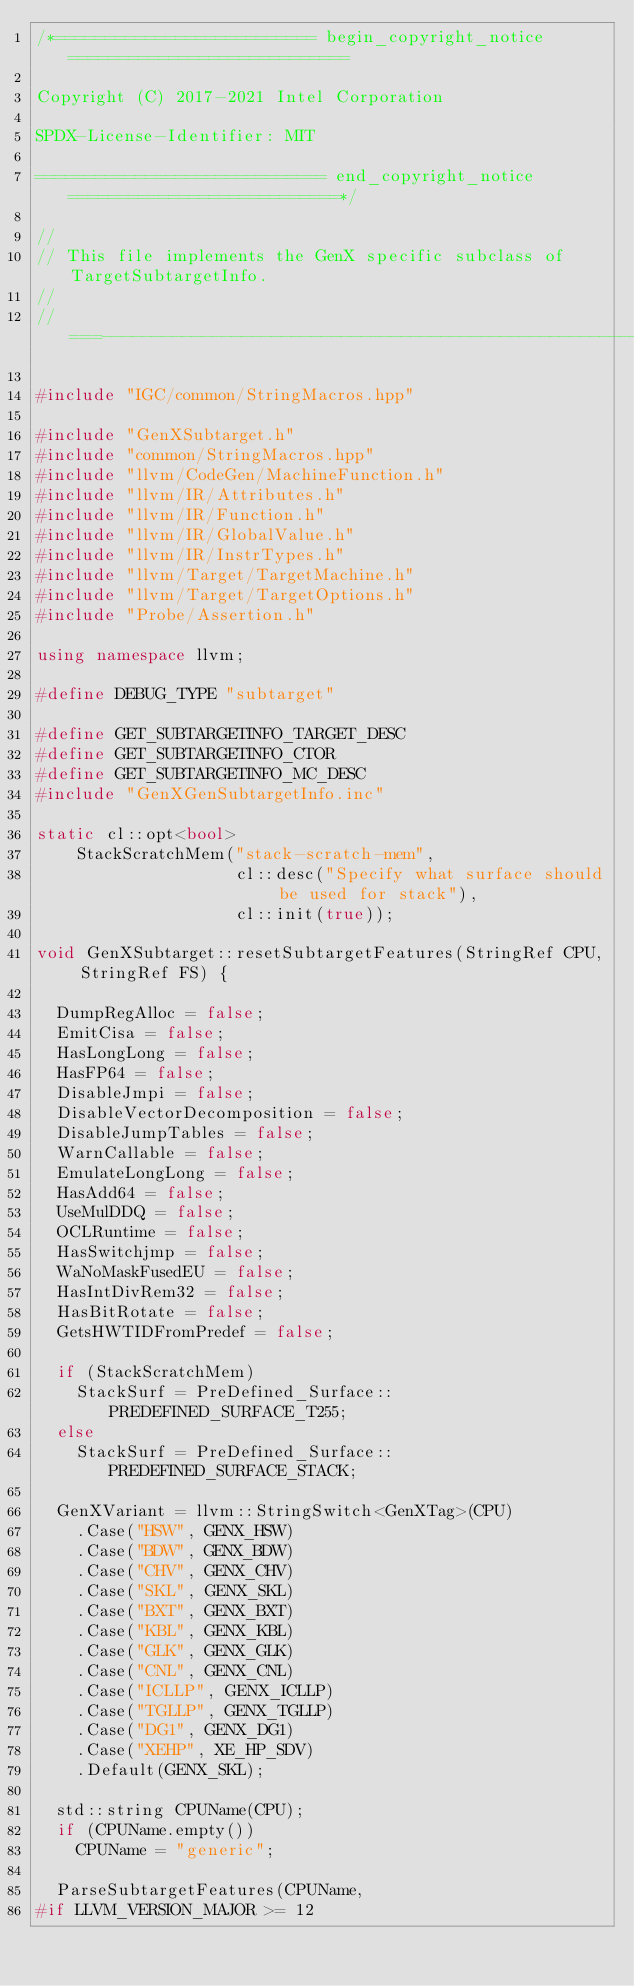<code> <loc_0><loc_0><loc_500><loc_500><_C++_>/*========================== begin_copyright_notice ============================

Copyright (C) 2017-2021 Intel Corporation

SPDX-License-Identifier: MIT

============================= end_copyright_notice ===========================*/

//
// This file implements the GenX specific subclass of TargetSubtargetInfo.
//
//===----------------------------------------------------------------------===//

#include "IGC/common/StringMacros.hpp"

#include "GenXSubtarget.h"
#include "common/StringMacros.hpp"
#include "llvm/CodeGen/MachineFunction.h"
#include "llvm/IR/Attributes.h"
#include "llvm/IR/Function.h"
#include "llvm/IR/GlobalValue.h"
#include "llvm/IR/InstrTypes.h"
#include "llvm/Target/TargetMachine.h"
#include "llvm/Target/TargetOptions.h"
#include "Probe/Assertion.h"

using namespace llvm;

#define DEBUG_TYPE "subtarget"

#define GET_SUBTARGETINFO_TARGET_DESC
#define GET_SUBTARGETINFO_CTOR
#define GET_SUBTARGETINFO_MC_DESC
#include "GenXGenSubtargetInfo.inc"

static cl::opt<bool>
    StackScratchMem("stack-scratch-mem",
                    cl::desc("Specify what surface should be used for stack"),
                    cl::init(true));

void GenXSubtarget::resetSubtargetFeatures(StringRef CPU, StringRef FS) {

  DumpRegAlloc = false;
  EmitCisa = false;
  HasLongLong = false;
  HasFP64 = false;
  DisableJmpi = false;
  DisableVectorDecomposition = false;
  DisableJumpTables = false;
  WarnCallable = false;
  EmulateLongLong = false;
  HasAdd64 = false;
  UseMulDDQ = false;
  OCLRuntime = false;
  HasSwitchjmp = false;
  WaNoMaskFusedEU = false;
  HasIntDivRem32 = false;
  HasBitRotate = false;
  GetsHWTIDFromPredef = false;

  if (StackScratchMem)
    StackSurf = PreDefined_Surface::PREDEFINED_SURFACE_T255;
  else
    StackSurf = PreDefined_Surface::PREDEFINED_SURFACE_STACK;

  GenXVariant = llvm::StringSwitch<GenXTag>(CPU)
    .Case("HSW", GENX_HSW)
    .Case("BDW", GENX_BDW)
    .Case("CHV", GENX_CHV)
    .Case("SKL", GENX_SKL)
    .Case("BXT", GENX_BXT)
    .Case("KBL", GENX_KBL)
    .Case("GLK", GENX_GLK)
    .Case("CNL", GENX_CNL)
    .Case("ICLLP", GENX_ICLLP)
    .Case("TGLLP", GENX_TGLLP)
    .Case("DG1", GENX_DG1)
    .Case("XEHP", XE_HP_SDV)
    .Default(GENX_SKL);

  std::string CPUName(CPU);
  if (CPUName.empty())
    CPUName = "generic";

  ParseSubtargetFeatures(CPUName,
#if LLVM_VERSION_MAJOR >= 12</code> 